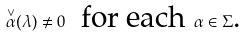Convert formula to latex. <formula><loc_0><loc_0><loc_500><loc_500>\overset { \vee } { \alpha } ( \lambda ) \neq 0 \text { \ for each } \alpha \in \Sigma \text {.}</formula> 